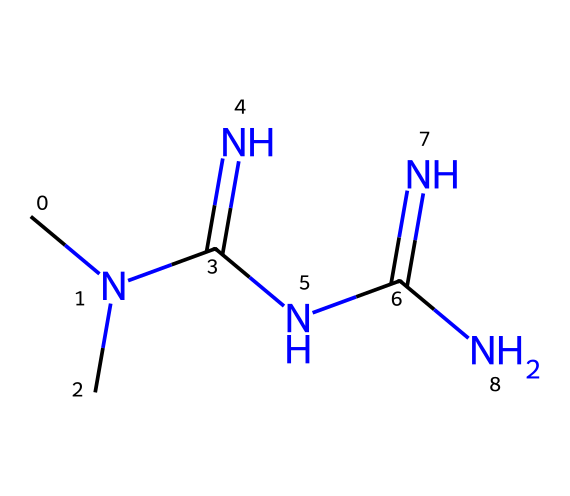How many nitrogen atoms are present in metformin? By analyzing the SMILES representation, we can see that the formula includes multiple "N" symbols, indicating nitrogen atoms. Counting these symbols shows there are 5 nitrogen atoms.
Answer: 5 What is the primary functional group present in metformin? In the structure, the presence of the nitrogen atoms connected to carbon and themselves suggests that metformin primarily consists of amine or guanidine functional groups, common in such medicinal compounds.
Answer: guanidine How many carbon atoms are in the metformin structure? In the SMILES, the letter "C" represents carbon atoms. By counting the "C" symbols, we find there are 2 carbon atoms in the structure.
Answer: 2 What type of medicinal compound is metformin classified as? Metformin is specifically classified as a biguanide based on its molecular structure, which features a chain of nitrogen atoms that is characteristic of this class of compounds.
Answer: biguanide What type of medicinal properties does metformin exhibit? Analyzing the structure shows it possesses properties that help regulate blood sugar levels, which categorizes it as an antidiabetic medication.
Answer: antidiabetic Which molecular components contribute to metformin's efficacy in diabetes management? The presence of multiple amine groups in its structure provides metformin with the ability to interact effectively with biological pathways, aiding in reducing glucose production in the liver and improving insulin sensitivity.
Answer: amine groups 